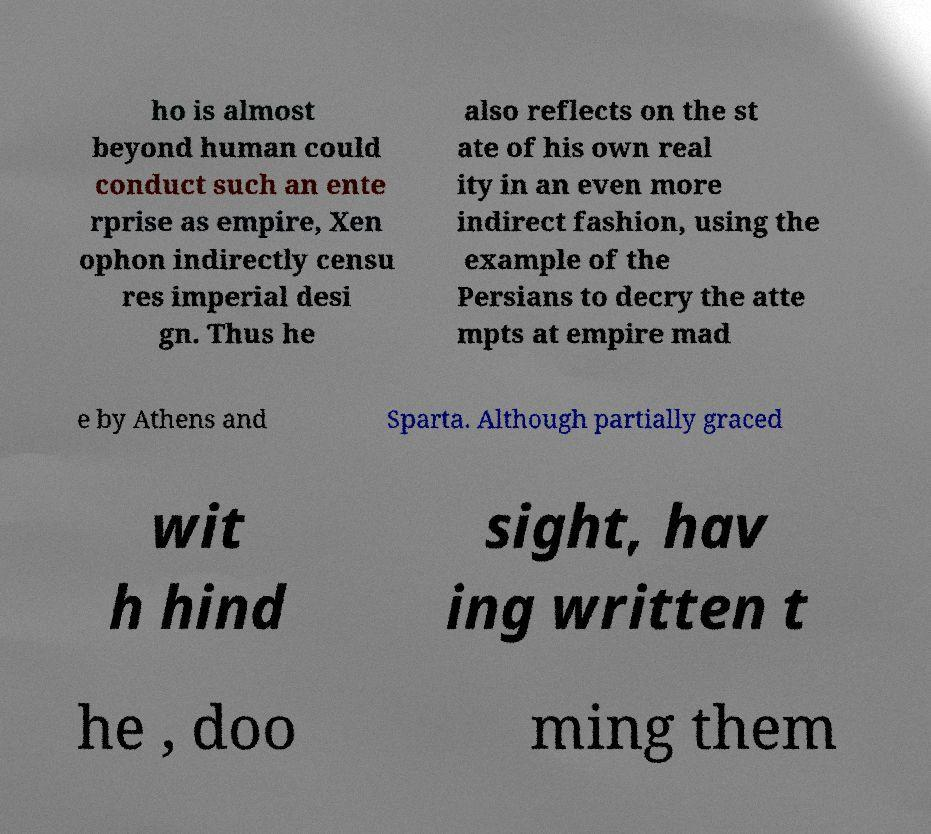Please identify and transcribe the text found in this image. ho is almost beyond human could conduct such an ente rprise as empire, Xen ophon indirectly censu res imperial desi gn. Thus he also reflects on the st ate of his own real ity in an even more indirect fashion, using the example of the Persians to decry the atte mpts at empire mad e by Athens and Sparta. Although partially graced wit h hind sight, hav ing written t he , doo ming them 